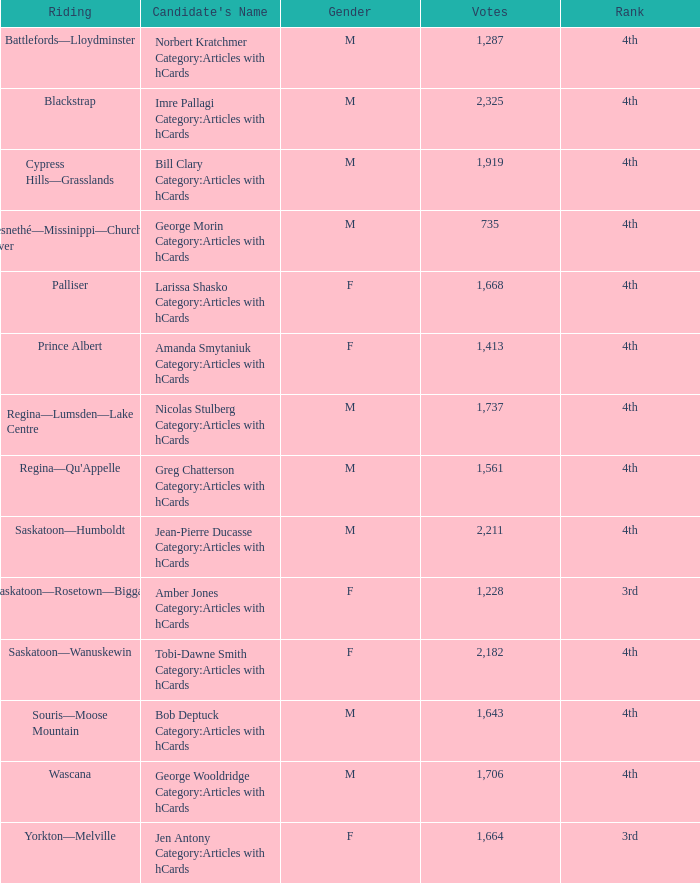What is the position of the candidate with over 2,211 votes? 4th. 